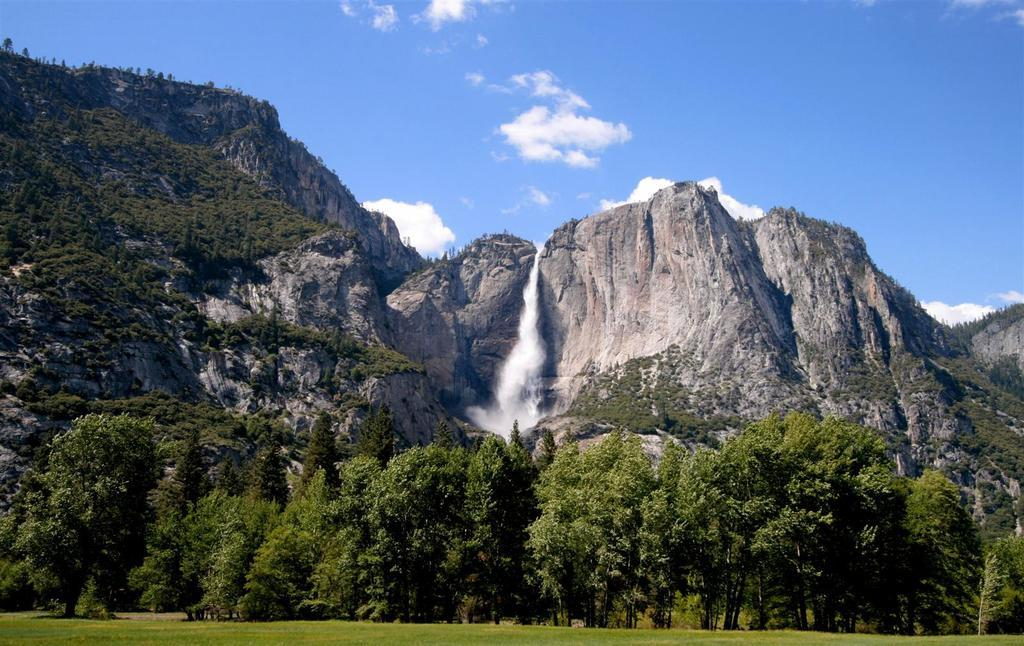What type of vegetation is present in the image? There are many plants and trees in the image. How are the plants and trees situated in relation to the grass surface? The plants and trees are behind a grass surface. What geographical feature can be seen in the background of the image? There is a huge mountain in the background of the image. Is there any water feature visible in the image? Yes, there is a waterfall between the mountain in the image. Can you tell me how many wrens are perched on the branches of the trees in the image? There are no wrens present in the image; it only features plants, trees, a grass surface, a mountain, and a waterfall. 